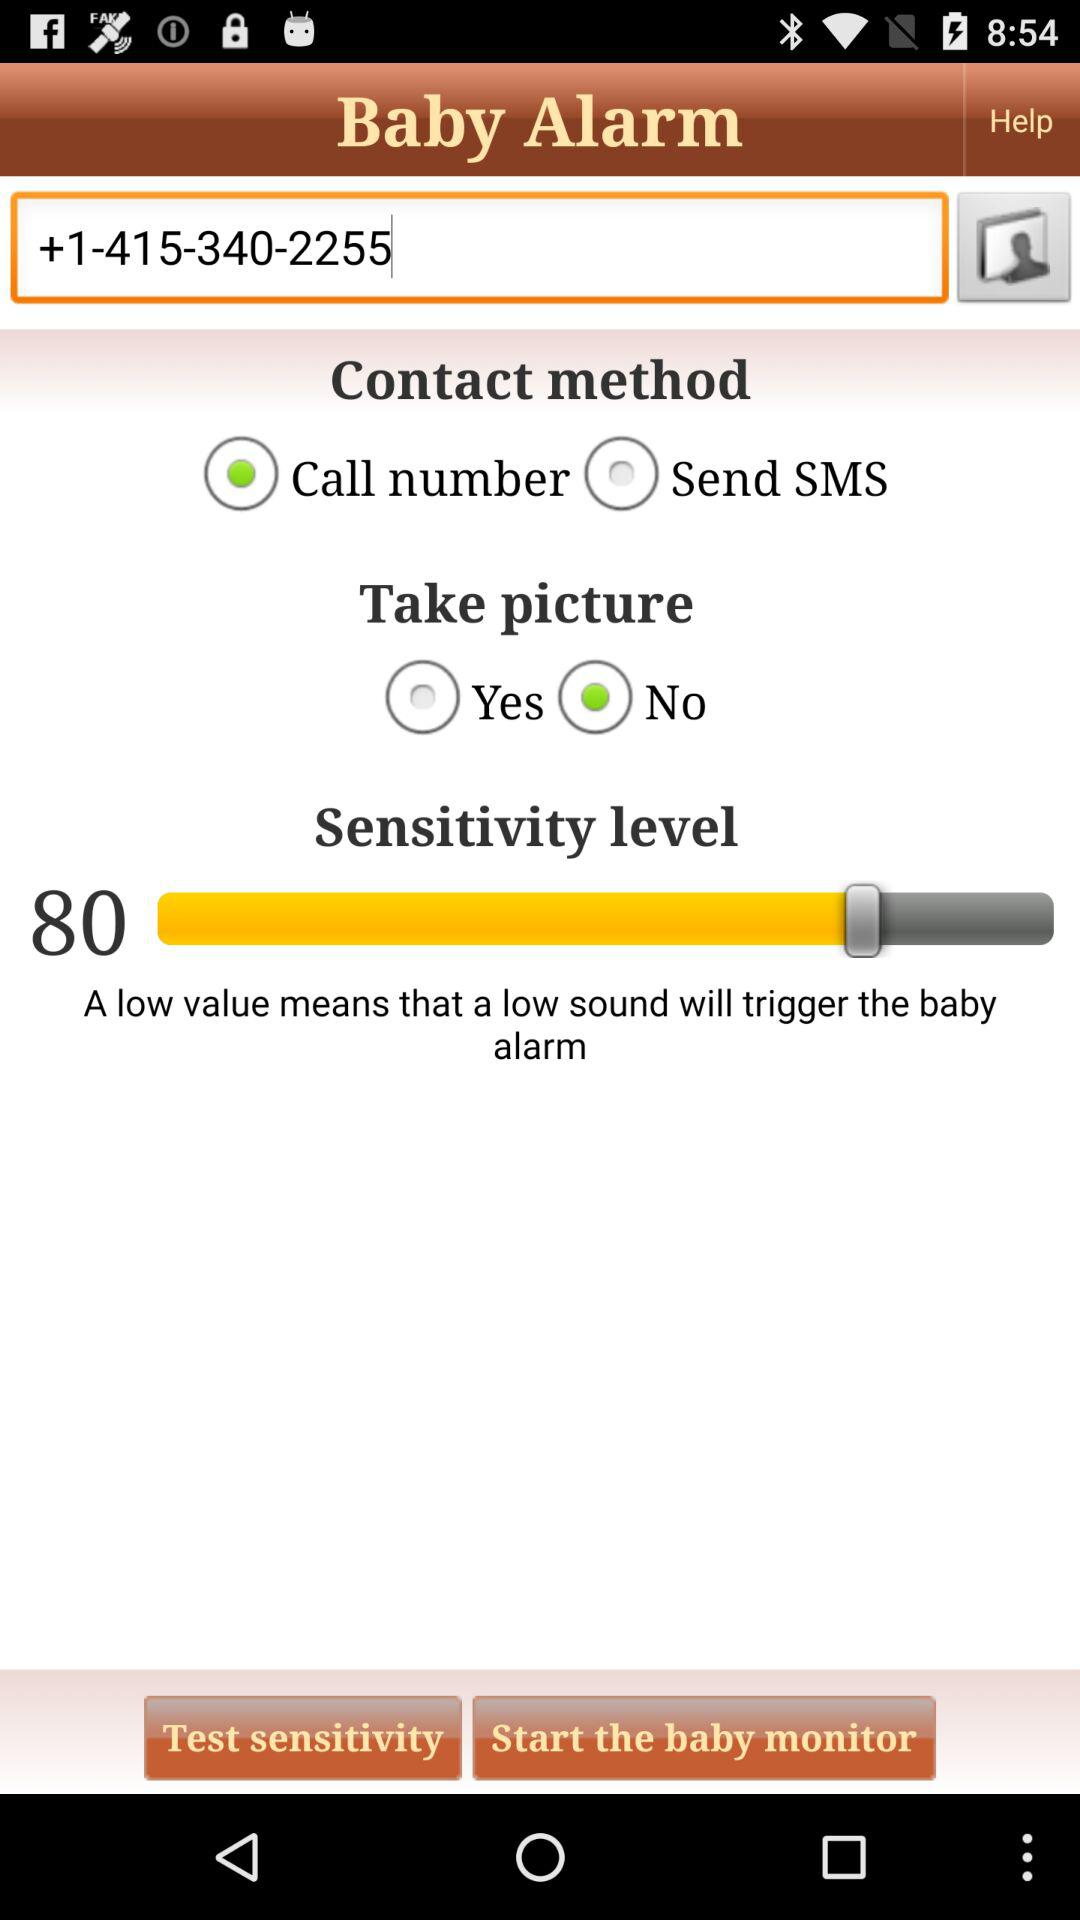What is the sensitivity level? The sensitivity level is 80. 